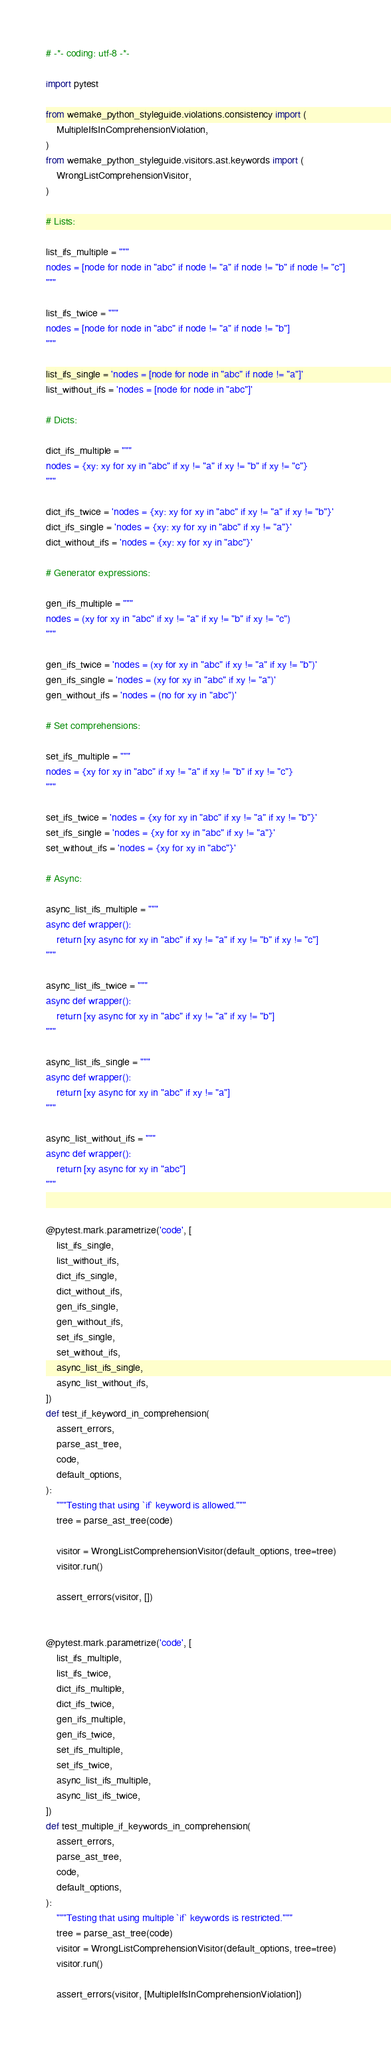<code> <loc_0><loc_0><loc_500><loc_500><_Python_># -*- coding: utf-8 -*-

import pytest

from wemake_python_styleguide.violations.consistency import (
    MultipleIfsInComprehensionViolation,
)
from wemake_python_styleguide.visitors.ast.keywords import (
    WrongListComprehensionVisitor,
)

# Lists:

list_ifs_multiple = """
nodes = [node for node in "abc" if node != "a" if node != "b" if node != "c"]
"""

list_ifs_twice = """
nodes = [node for node in "abc" if node != "a" if node != "b"]
"""

list_ifs_single = 'nodes = [node for node in "abc" if node != "a"]'
list_without_ifs = 'nodes = [node for node in "abc"]'

# Dicts:

dict_ifs_multiple = """
nodes = {xy: xy for xy in "abc" if xy != "a" if xy != "b" if xy != "c"}
"""

dict_ifs_twice = 'nodes = {xy: xy for xy in "abc" if xy != "a" if xy != "b"}'
dict_ifs_single = 'nodes = {xy: xy for xy in "abc" if xy != "a"}'
dict_without_ifs = 'nodes = {xy: xy for xy in "abc"}'

# Generator expressions:

gen_ifs_multiple = """
nodes = (xy for xy in "abc" if xy != "a" if xy != "b" if xy != "c")
"""

gen_ifs_twice = 'nodes = (xy for xy in "abc" if xy != "a" if xy != "b")'
gen_ifs_single = 'nodes = (xy for xy in "abc" if xy != "a")'
gen_without_ifs = 'nodes = (no for xy in "abc")'

# Set comprehensions:

set_ifs_multiple = """
nodes = {xy for xy in "abc" if xy != "a" if xy != "b" if xy != "c"}
"""

set_ifs_twice = 'nodes = {xy for xy in "abc" if xy != "a" if xy != "b"}'
set_ifs_single = 'nodes = {xy for xy in "abc" if xy != "a"}'
set_without_ifs = 'nodes = {xy for xy in "abc"}'

# Async:

async_list_ifs_multiple = """
async def wrapper():
    return [xy async for xy in "abc" if xy != "a" if xy != "b" if xy != "c"]
"""

async_list_ifs_twice = """
async def wrapper():
    return [xy async for xy in "abc" if xy != "a" if xy != "b"]
"""

async_list_ifs_single = """
async def wrapper():
    return [xy async for xy in "abc" if xy != "a"]
"""

async_list_without_ifs = """
async def wrapper():
    return [xy async for xy in "abc"]
"""


@pytest.mark.parametrize('code', [
    list_ifs_single,
    list_without_ifs,
    dict_ifs_single,
    dict_without_ifs,
    gen_ifs_single,
    gen_without_ifs,
    set_ifs_single,
    set_without_ifs,
    async_list_ifs_single,
    async_list_without_ifs,
])
def test_if_keyword_in_comprehension(
    assert_errors,
    parse_ast_tree,
    code,
    default_options,
):
    """Testing that using `if` keyword is allowed."""
    tree = parse_ast_tree(code)

    visitor = WrongListComprehensionVisitor(default_options, tree=tree)
    visitor.run()

    assert_errors(visitor, [])


@pytest.mark.parametrize('code', [
    list_ifs_multiple,
    list_ifs_twice,
    dict_ifs_multiple,
    dict_ifs_twice,
    gen_ifs_multiple,
    gen_ifs_twice,
    set_ifs_multiple,
    set_ifs_twice,
    async_list_ifs_multiple,
    async_list_ifs_twice,
])
def test_multiple_if_keywords_in_comprehension(
    assert_errors,
    parse_ast_tree,
    code,
    default_options,
):
    """Testing that using multiple `if` keywords is restricted."""
    tree = parse_ast_tree(code)
    visitor = WrongListComprehensionVisitor(default_options, tree=tree)
    visitor.run()

    assert_errors(visitor, [MultipleIfsInComprehensionViolation])
</code> 